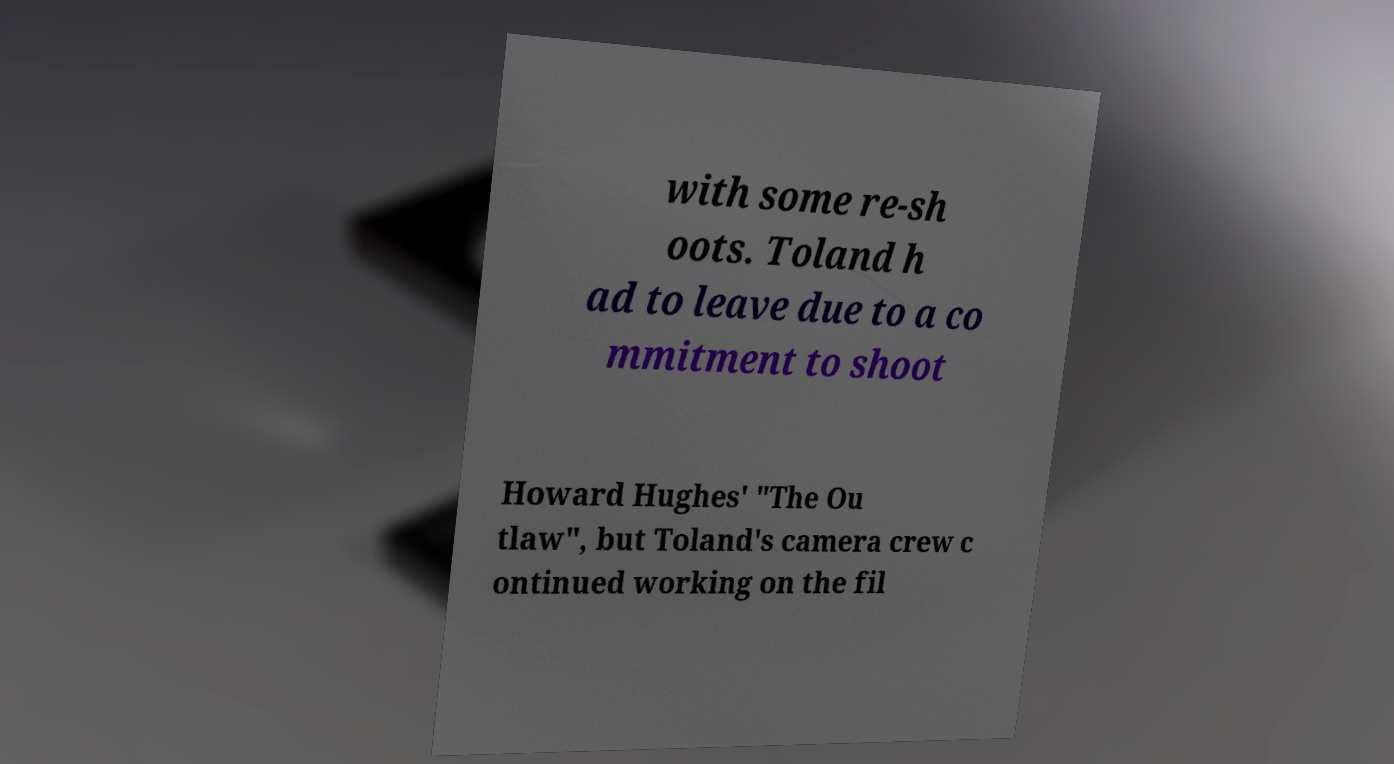For documentation purposes, I need the text within this image transcribed. Could you provide that? with some re-sh oots. Toland h ad to leave due to a co mmitment to shoot Howard Hughes' "The Ou tlaw", but Toland's camera crew c ontinued working on the fil 